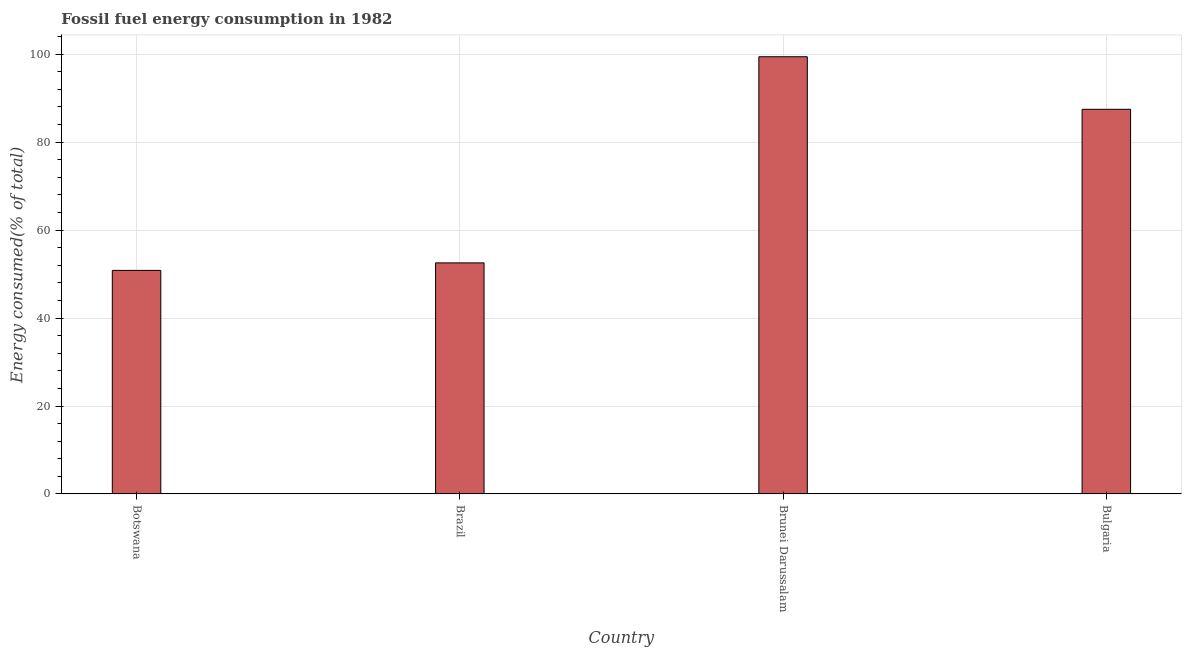Does the graph contain any zero values?
Ensure brevity in your answer.  No. Does the graph contain grids?
Ensure brevity in your answer.  Yes. What is the title of the graph?
Provide a succinct answer. Fossil fuel energy consumption in 1982. What is the label or title of the X-axis?
Your answer should be compact. Country. What is the label or title of the Y-axis?
Provide a succinct answer. Energy consumed(% of total). What is the fossil fuel energy consumption in Botswana?
Offer a terse response. 50.84. Across all countries, what is the maximum fossil fuel energy consumption?
Give a very brief answer. 99.43. Across all countries, what is the minimum fossil fuel energy consumption?
Offer a very short reply. 50.84. In which country was the fossil fuel energy consumption maximum?
Your answer should be very brief. Brunei Darussalam. In which country was the fossil fuel energy consumption minimum?
Your answer should be compact. Botswana. What is the sum of the fossil fuel energy consumption?
Your answer should be compact. 290.3. What is the difference between the fossil fuel energy consumption in Botswana and Brunei Darussalam?
Provide a short and direct response. -48.59. What is the average fossil fuel energy consumption per country?
Make the answer very short. 72.57. What is the median fossil fuel energy consumption?
Your response must be concise. 70.01. In how many countries, is the fossil fuel energy consumption greater than 20 %?
Offer a very short reply. 4. What is the ratio of the fossil fuel energy consumption in Brunei Darussalam to that in Bulgaria?
Ensure brevity in your answer.  1.14. Is the difference between the fossil fuel energy consumption in Brazil and Bulgaria greater than the difference between any two countries?
Give a very brief answer. No. What is the difference between the highest and the second highest fossil fuel energy consumption?
Provide a succinct answer. 11.95. What is the difference between the highest and the lowest fossil fuel energy consumption?
Give a very brief answer. 48.59. In how many countries, is the fossil fuel energy consumption greater than the average fossil fuel energy consumption taken over all countries?
Provide a succinct answer. 2. How many bars are there?
Keep it short and to the point. 4. How many countries are there in the graph?
Make the answer very short. 4. What is the difference between two consecutive major ticks on the Y-axis?
Keep it short and to the point. 20. What is the Energy consumed(% of total) in Botswana?
Keep it short and to the point. 50.84. What is the Energy consumed(% of total) of Brazil?
Provide a short and direct response. 52.55. What is the Energy consumed(% of total) in Brunei Darussalam?
Offer a terse response. 99.43. What is the Energy consumed(% of total) in Bulgaria?
Your answer should be very brief. 87.48. What is the difference between the Energy consumed(% of total) in Botswana and Brazil?
Ensure brevity in your answer.  -1.71. What is the difference between the Energy consumed(% of total) in Botswana and Brunei Darussalam?
Your answer should be very brief. -48.59. What is the difference between the Energy consumed(% of total) in Botswana and Bulgaria?
Make the answer very short. -36.64. What is the difference between the Energy consumed(% of total) in Brazil and Brunei Darussalam?
Keep it short and to the point. -46.88. What is the difference between the Energy consumed(% of total) in Brazil and Bulgaria?
Your answer should be compact. -34.93. What is the difference between the Energy consumed(% of total) in Brunei Darussalam and Bulgaria?
Your response must be concise. 11.95. What is the ratio of the Energy consumed(% of total) in Botswana to that in Brunei Darussalam?
Ensure brevity in your answer.  0.51. What is the ratio of the Energy consumed(% of total) in Botswana to that in Bulgaria?
Make the answer very short. 0.58. What is the ratio of the Energy consumed(% of total) in Brazil to that in Brunei Darussalam?
Your answer should be very brief. 0.53. What is the ratio of the Energy consumed(% of total) in Brazil to that in Bulgaria?
Your answer should be very brief. 0.6. What is the ratio of the Energy consumed(% of total) in Brunei Darussalam to that in Bulgaria?
Give a very brief answer. 1.14. 